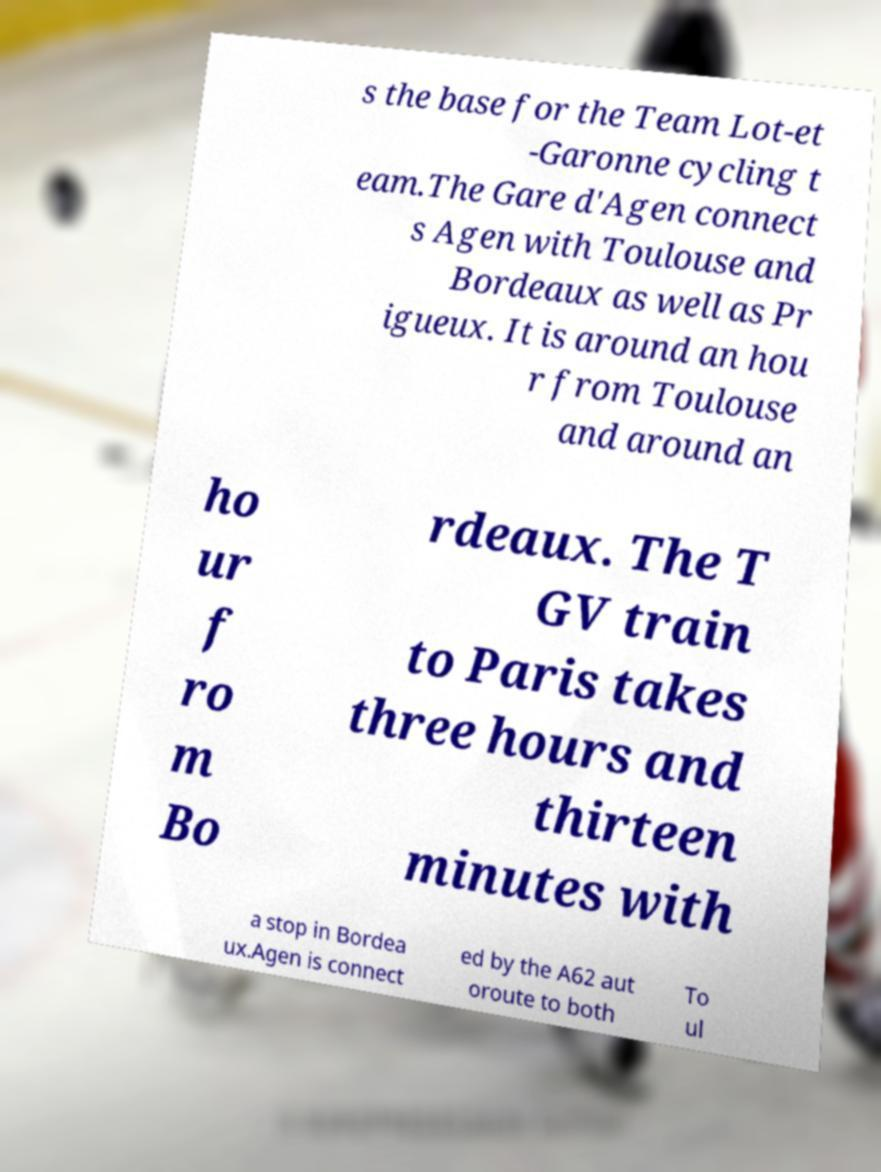Could you extract and type out the text from this image? s the base for the Team Lot-et -Garonne cycling t eam.The Gare d'Agen connect s Agen with Toulouse and Bordeaux as well as Pr igueux. It is around an hou r from Toulouse and around an ho ur f ro m Bo rdeaux. The T GV train to Paris takes three hours and thirteen minutes with a stop in Bordea ux.Agen is connect ed by the A62 aut oroute to both To ul 